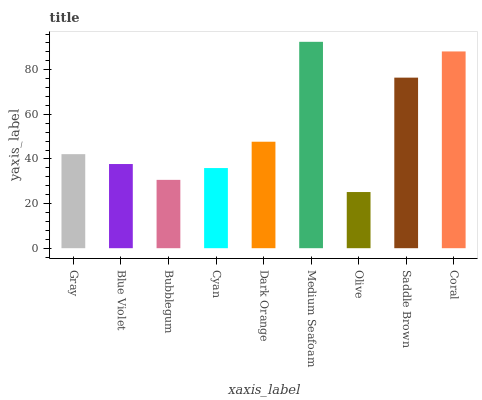Is Olive the minimum?
Answer yes or no. Yes. Is Medium Seafoam the maximum?
Answer yes or no. Yes. Is Blue Violet the minimum?
Answer yes or no. No. Is Blue Violet the maximum?
Answer yes or no. No. Is Gray greater than Blue Violet?
Answer yes or no. Yes. Is Blue Violet less than Gray?
Answer yes or no. Yes. Is Blue Violet greater than Gray?
Answer yes or no. No. Is Gray less than Blue Violet?
Answer yes or no. No. Is Gray the high median?
Answer yes or no. Yes. Is Gray the low median?
Answer yes or no. Yes. Is Bubblegum the high median?
Answer yes or no. No. Is Bubblegum the low median?
Answer yes or no. No. 